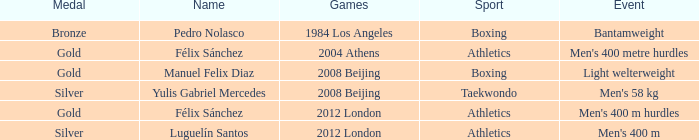Which medal was won in the 2008 beijing games in the category of taekwondo? Silver. 